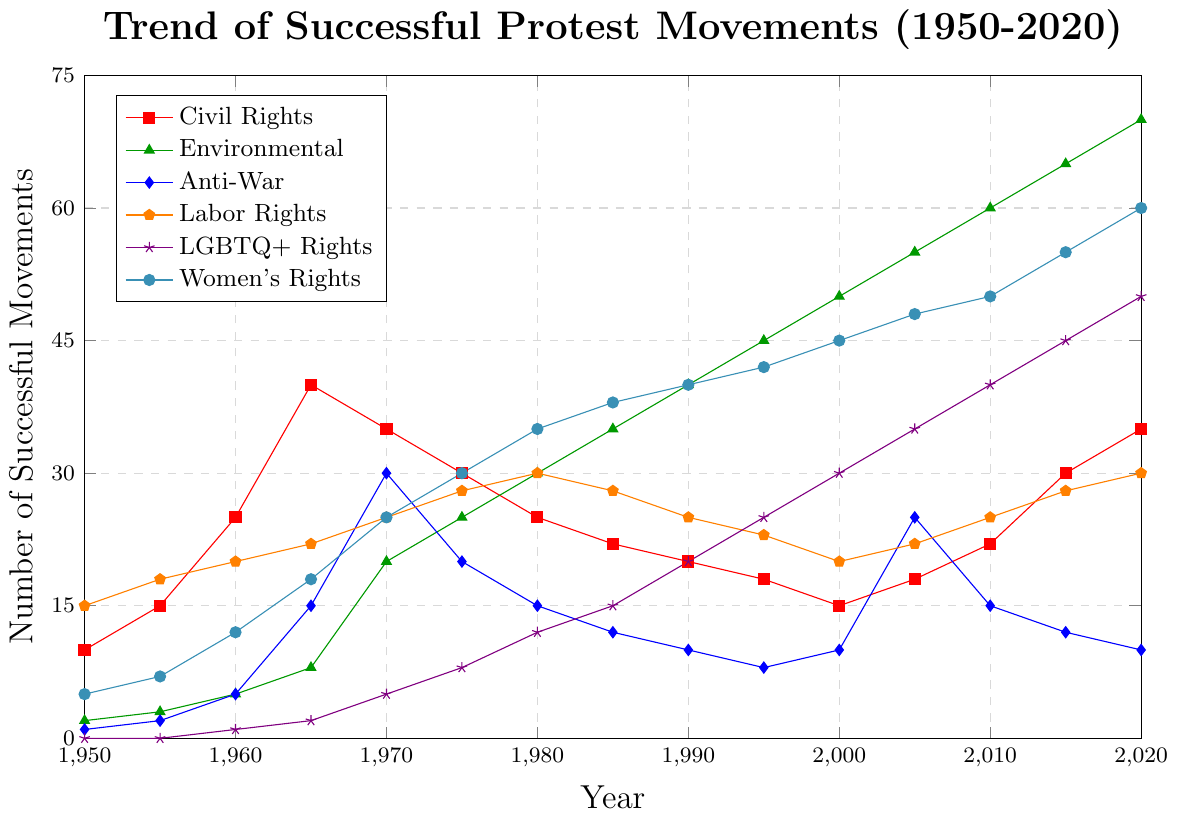What is the highest number of successful Civil Rights movements in any year between 1950 and 2020? Observing the red line for Civil Rights, the peak occurs around 1965 where the number reaches 40.
Answer: 40 Which cause had the least number of successful movements in 1960? In 1960, looking at all the categories, LGBTQ+ Rights (represented by the violet line) has only 1 successful movement, which is the lowest.
Answer: LGBTQ+ Rights Between 1965 and 1975, which cause experienced the largest decline in successful protests? Analyzing the period from 1965 to 1975, the Anti-War protests (blue line) moved from 15 successful movements to 20, which is an increase. All other movements either increased or remained stable. There is no decline for any cause, hence no largest decline occurred during this period.
Answer: None What was the total number of successful Labor Rights movements from 1990 to 2000? Summing the values for Labor Rights (orange line) from 1990 (25), 1995 (23), and 2000 (20), we get a total of 25 + 23 + 20 = 68.
Answer: 68 How does the number of successful Women's Rights movements in 1980 compare to that in 2020? Comparing the cyan line values at 1980 (35) and 2020 (60), we see that there are 25 more successful Women's Rights movements in 2020.
Answer: 25 more in 2020 Which cause shows a steady increase throughout the period from 1950 to 2020 without any decline? The Environmental movement (green line) steadily increases from 2 in 1950 to 70 in 2020 without any decline.
Answer: Environmental What is the difference between the highest and lowest number of successful LGBTQ+ Rights movements between 1950 and 2020? The maximum for LGBTQ+ Rights (violet line) is 50 in 2020 and the minimum is 0 in 1950 and 1955. The difference is 50 - 0 = 50.
Answer: 50 Which two causes had similar trends between 2000 and 2020? Observing the lines, both Women's Rights (cyan) and LGBTQ+ Rights (violet) show a consistent rise without any dips from 2000 to 2020.
Answer: Women's Rights and LGBTQ+ Rights 